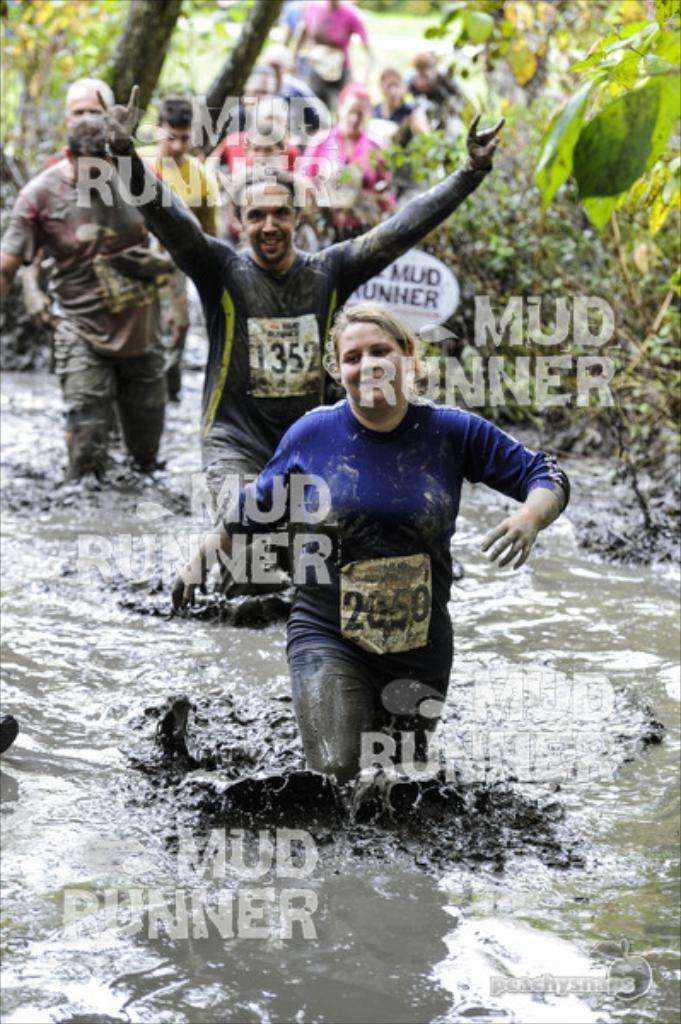How many people are in the image? There is a group of people in the image. What can be seen on the image that might indicate it is a copy or has been printed? There are watermarks in the image. What is visible in the image besides the people? Water and plants are present in the image. Can you tell me how many toes the manager has in the image? There is no manager present in the image, and therefore no toes to count. 